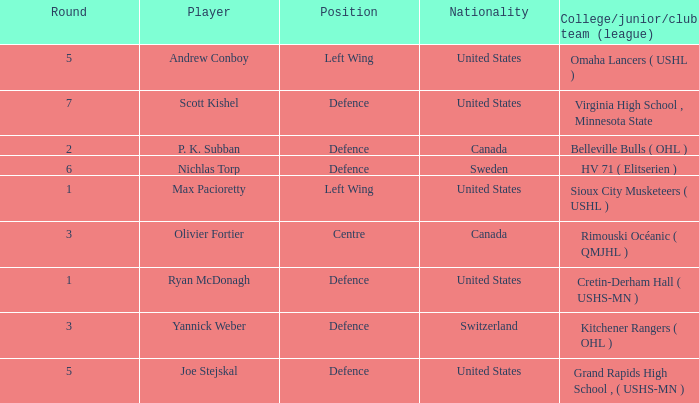Which player from the United States plays defence and was chosen before round 5? Ryan McDonagh. 